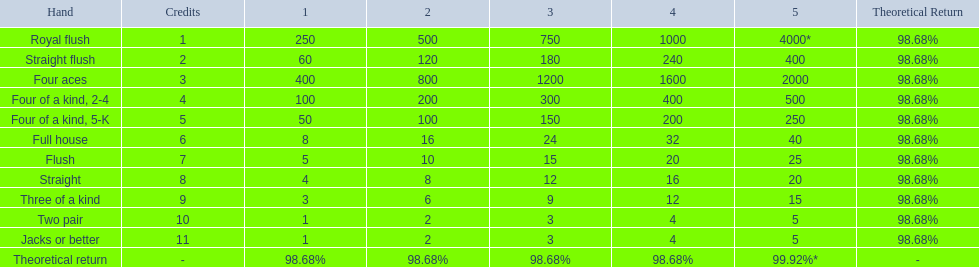Parse the table in full. {'header': ['Hand', 'Credits', '1', '2', '3', '4', '5', 'Theoretical Return'], 'rows': [['Royal flush', '1', '250', '500', '750', '1000', '4000*', '98.68%'], ['Straight flush', '2', '60', '120', '180', '240', '400', '98.68%'], ['Four aces', '3', '400', '800', '1200', '1600', '2000', '98.68%'], ['Four of a kind, 2-4', '4', '100', '200', '300', '400', '500', '98.68%'], ['Four of a kind, 5-K', '5', '50', '100', '150', '200', '250', '98.68%'], ['Full house', '6', '8', '16', '24', '32', '40', '98.68%'], ['Flush', '7', '5', '10', '15', '20', '25', '98.68%'], ['Straight', '8', '4', '8', '12', '16', '20', '98.68%'], ['Three of a kind', '9', '3', '6', '9', '12', '15', '98.68%'], ['Two pair', '10', '1', '2', '3', '4', '5', '98.68%'], ['Jacks or better', '11', '1', '2', '3', '4', '5', '98.68%'], ['Theoretical return', '-', '98.68%', '98.68%', '98.68%', '98.68%', '99.92%*', '-']]} What are the different hands? Royal flush, Straight flush, Four aces, Four of a kind, 2-4, Four of a kind, 5-K, Full house, Flush, Straight, Three of a kind, Two pair, Jacks or better. Which hands have a higher standing than a straight? Royal flush, Straight flush, Four aces, Four of a kind, 2-4, Four of a kind, 5-K, Full house, Flush. Of these, which hand is the next highest after a straight? Flush. 